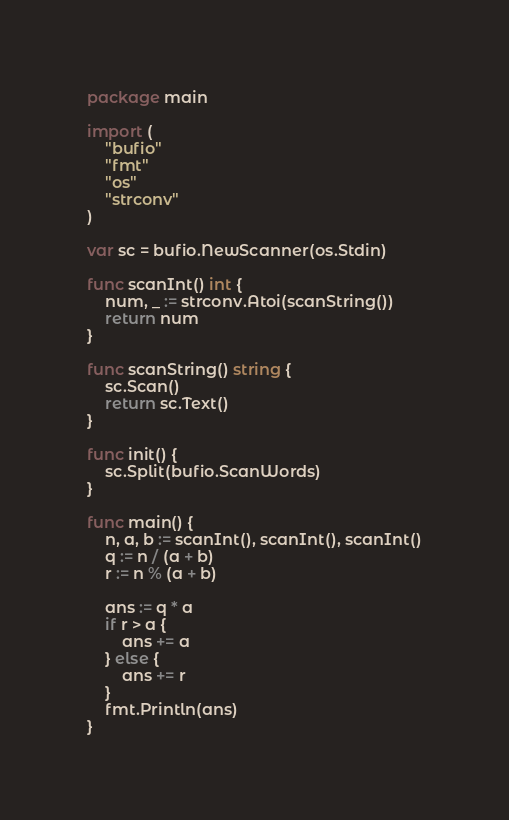Convert code to text. <code><loc_0><loc_0><loc_500><loc_500><_Go_>package main

import (
	"bufio"
	"fmt"
	"os"
	"strconv"
)

var sc = bufio.NewScanner(os.Stdin)

func scanInt() int {
	num, _ := strconv.Atoi(scanString())
	return num
}

func scanString() string {
	sc.Scan()
	return sc.Text()
}

func init() {
	sc.Split(bufio.ScanWords)
}

func main() {
	n, a, b := scanInt(), scanInt(), scanInt()
	q := n / (a + b)
	r := n % (a + b)

	ans := q * a
	if r > a {
		ans += a
	} else {
		ans += r
	}
	fmt.Println(ans)
}
</code> 